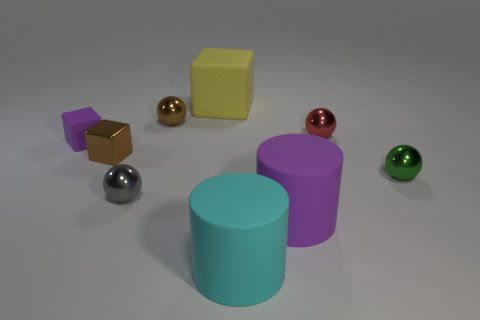Can you tell me more about the different materials represented in this image? Certainly! The image shows objects that appear to have various textures and reflective properties. The cyan and purple objects have a matte finish, typical of items made from materials like rubber or plastic. In contrast, the smaller spheres have shiny surfaces, suggesting they could be metallic or polished stone. The variations in sheen and reflectivity add to the visual complexity of the scene. 